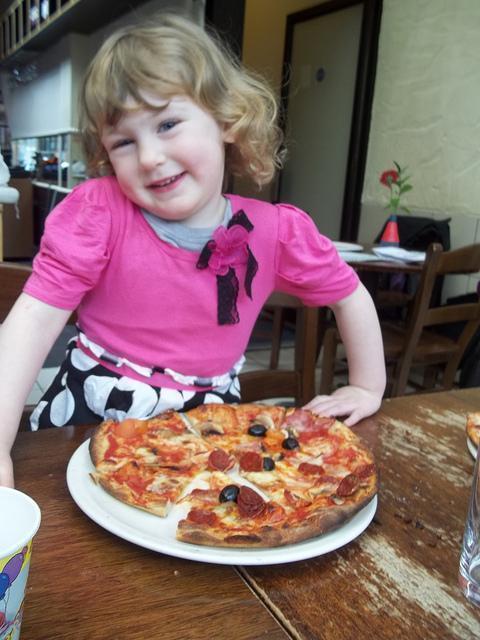What fruit might this person eat first?
Indicate the correct choice and explain in the format: 'Answer: answer
Rationale: rationale.'
Options: Kiwi, olives, acai berries, ugli. Answer: olives.
Rationale: The person wants the olives. 